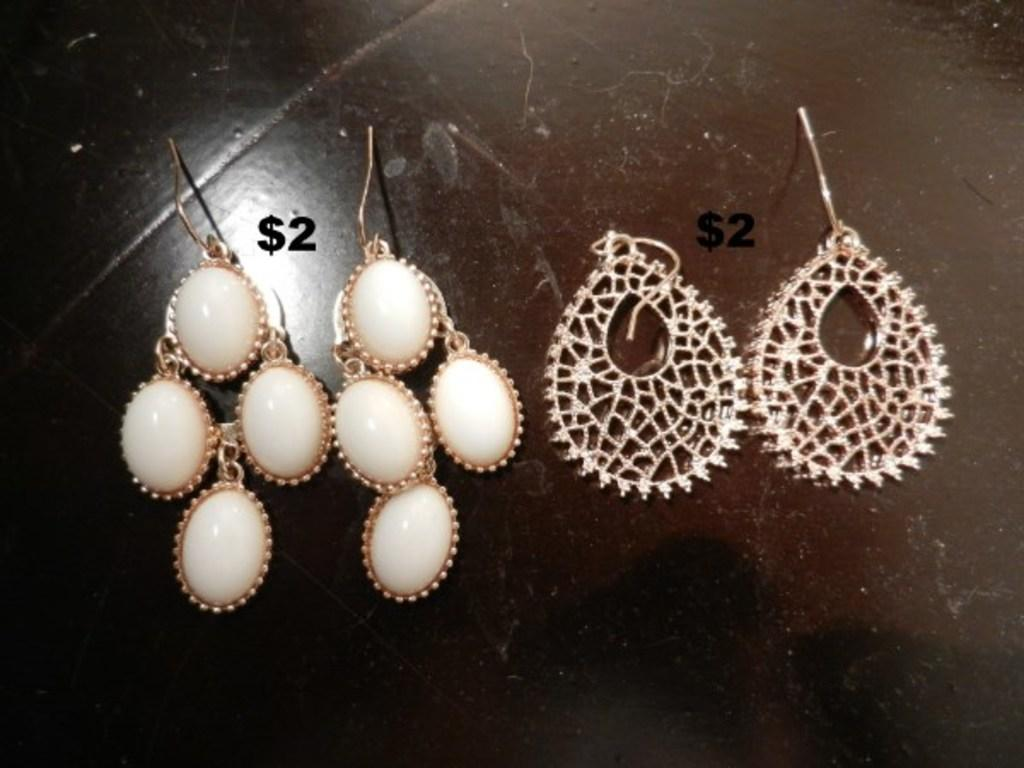How many pairs of earrings are visible in the image? There are two pairs of earrings in the image. Where are the earrings located in the image? The earrings are on a platform. What type of tools does the carpenter use in the image? There is no carpenter present in the image, so it is not possible to determine what tools they might use. 